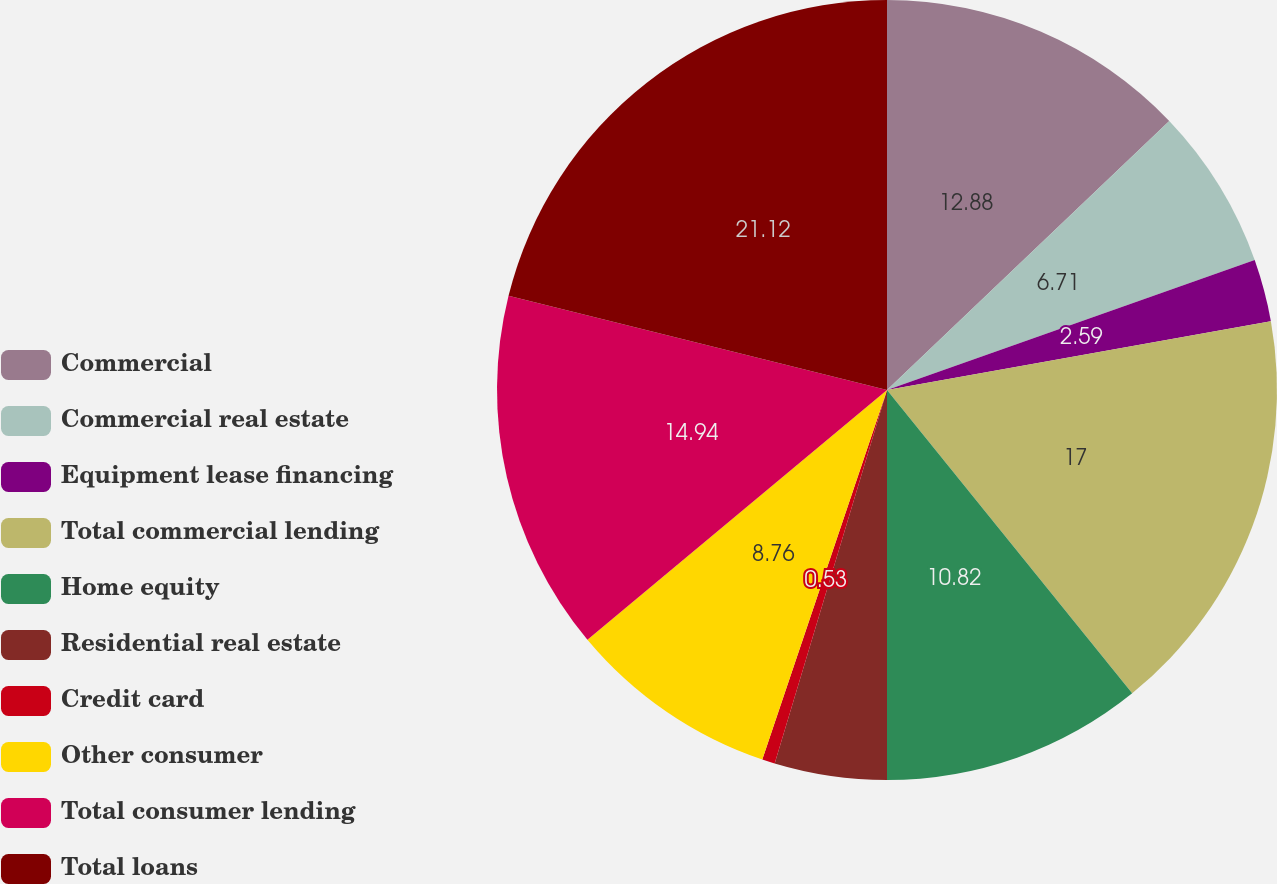<chart> <loc_0><loc_0><loc_500><loc_500><pie_chart><fcel>Commercial<fcel>Commercial real estate<fcel>Equipment lease financing<fcel>Total commercial lending<fcel>Home equity<fcel>Residential real estate<fcel>Credit card<fcel>Other consumer<fcel>Total consumer lending<fcel>Total loans<nl><fcel>12.88%<fcel>6.71%<fcel>2.59%<fcel>17.0%<fcel>10.82%<fcel>4.65%<fcel>0.53%<fcel>8.76%<fcel>14.94%<fcel>21.12%<nl></chart> 